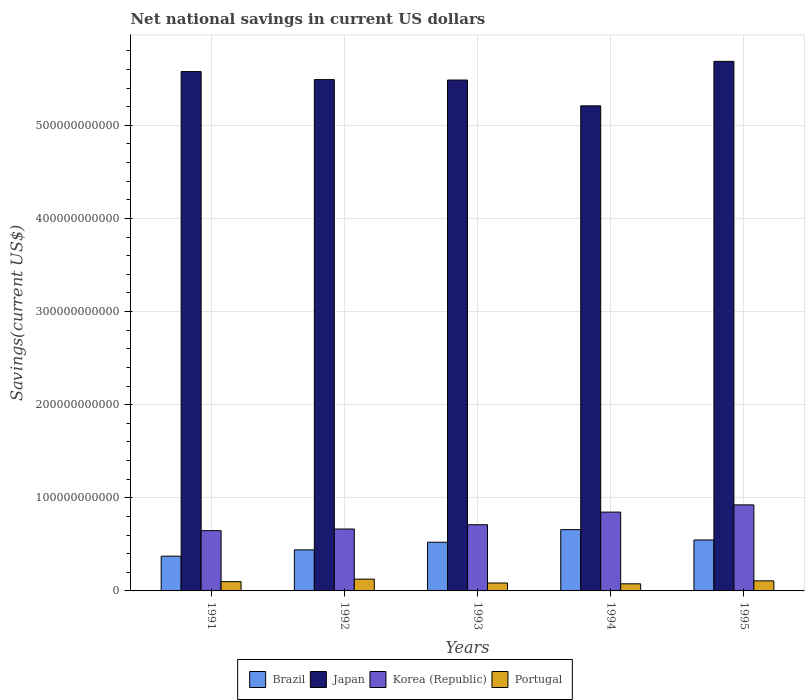Are the number of bars per tick equal to the number of legend labels?
Keep it short and to the point. Yes. Are the number of bars on each tick of the X-axis equal?
Give a very brief answer. Yes. How many bars are there on the 5th tick from the left?
Your answer should be very brief. 4. How many bars are there on the 2nd tick from the right?
Ensure brevity in your answer.  4. In how many cases, is the number of bars for a given year not equal to the number of legend labels?
Provide a succinct answer. 0. What is the net national savings in Brazil in 1993?
Provide a short and direct response. 5.23e+1. Across all years, what is the maximum net national savings in Japan?
Your answer should be very brief. 5.69e+11. Across all years, what is the minimum net national savings in Brazil?
Your answer should be compact. 3.73e+1. In which year was the net national savings in Brazil minimum?
Ensure brevity in your answer.  1991. What is the total net national savings in Korea (Republic) in the graph?
Give a very brief answer. 3.79e+11. What is the difference between the net national savings in Brazil in 1992 and that in 1993?
Give a very brief answer. -8.19e+09. What is the difference between the net national savings in Brazil in 1992 and the net national savings in Korea (Republic) in 1995?
Keep it short and to the point. -4.83e+1. What is the average net national savings in Korea (Republic) per year?
Your answer should be compact. 7.58e+1. In the year 1995, what is the difference between the net national savings in Japan and net national savings in Portugal?
Offer a terse response. 5.58e+11. What is the ratio of the net national savings in Portugal in 1993 to that in 1995?
Your response must be concise. 0.79. What is the difference between the highest and the second highest net national savings in Brazil?
Your response must be concise. 1.11e+1. What is the difference between the highest and the lowest net national savings in Japan?
Keep it short and to the point. 4.78e+1. In how many years, is the net national savings in Portugal greater than the average net national savings in Portugal taken over all years?
Give a very brief answer. 3. What does the 4th bar from the left in 1995 represents?
Offer a terse response. Portugal. What does the 1st bar from the right in 1993 represents?
Offer a terse response. Portugal. Is it the case that in every year, the sum of the net national savings in Japan and net national savings in Brazil is greater than the net national savings in Korea (Republic)?
Provide a short and direct response. Yes. How many years are there in the graph?
Keep it short and to the point. 5. What is the difference between two consecutive major ticks on the Y-axis?
Provide a short and direct response. 1.00e+11. Are the values on the major ticks of Y-axis written in scientific E-notation?
Ensure brevity in your answer.  No. Does the graph contain any zero values?
Offer a terse response. No. What is the title of the graph?
Your answer should be very brief. Net national savings in current US dollars. What is the label or title of the Y-axis?
Make the answer very short. Savings(current US$). What is the Savings(current US$) in Brazil in 1991?
Provide a succinct answer. 3.73e+1. What is the Savings(current US$) in Japan in 1991?
Your answer should be very brief. 5.58e+11. What is the Savings(current US$) in Korea (Republic) in 1991?
Offer a terse response. 6.47e+1. What is the Savings(current US$) of Portugal in 1991?
Offer a terse response. 9.96e+09. What is the Savings(current US$) in Brazil in 1992?
Your response must be concise. 4.41e+1. What is the Savings(current US$) in Japan in 1992?
Your response must be concise. 5.49e+11. What is the Savings(current US$) of Korea (Republic) in 1992?
Your answer should be compact. 6.65e+1. What is the Savings(current US$) in Portugal in 1992?
Make the answer very short. 1.27e+1. What is the Savings(current US$) of Brazil in 1993?
Offer a terse response. 5.23e+1. What is the Savings(current US$) of Japan in 1993?
Your answer should be very brief. 5.49e+11. What is the Savings(current US$) of Korea (Republic) in 1993?
Your response must be concise. 7.11e+1. What is the Savings(current US$) of Portugal in 1993?
Keep it short and to the point. 8.51e+09. What is the Savings(current US$) in Brazil in 1994?
Give a very brief answer. 6.58e+1. What is the Savings(current US$) of Japan in 1994?
Ensure brevity in your answer.  5.21e+11. What is the Savings(current US$) of Korea (Republic) in 1994?
Your answer should be very brief. 8.46e+1. What is the Savings(current US$) in Portugal in 1994?
Provide a short and direct response. 7.64e+09. What is the Savings(current US$) in Brazil in 1995?
Ensure brevity in your answer.  5.47e+1. What is the Savings(current US$) of Japan in 1995?
Your answer should be very brief. 5.69e+11. What is the Savings(current US$) in Korea (Republic) in 1995?
Provide a short and direct response. 9.24e+1. What is the Savings(current US$) in Portugal in 1995?
Offer a very short reply. 1.08e+1. Across all years, what is the maximum Savings(current US$) in Brazil?
Your answer should be very brief. 6.58e+1. Across all years, what is the maximum Savings(current US$) of Japan?
Give a very brief answer. 5.69e+11. Across all years, what is the maximum Savings(current US$) of Korea (Republic)?
Provide a succinct answer. 9.24e+1. Across all years, what is the maximum Savings(current US$) in Portugal?
Your response must be concise. 1.27e+1. Across all years, what is the minimum Savings(current US$) in Brazil?
Provide a short and direct response. 3.73e+1. Across all years, what is the minimum Savings(current US$) of Japan?
Ensure brevity in your answer.  5.21e+11. Across all years, what is the minimum Savings(current US$) in Korea (Republic)?
Your answer should be compact. 6.47e+1. Across all years, what is the minimum Savings(current US$) of Portugal?
Keep it short and to the point. 7.64e+09. What is the total Savings(current US$) of Brazil in the graph?
Offer a terse response. 2.54e+11. What is the total Savings(current US$) in Japan in the graph?
Offer a terse response. 2.74e+12. What is the total Savings(current US$) of Korea (Republic) in the graph?
Offer a terse response. 3.79e+11. What is the total Savings(current US$) in Portugal in the graph?
Make the answer very short. 4.96e+1. What is the difference between the Savings(current US$) in Brazil in 1991 and that in 1992?
Make the answer very short. -6.80e+09. What is the difference between the Savings(current US$) in Japan in 1991 and that in 1992?
Provide a short and direct response. 8.63e+09. What is the difference between the Savings(current US$) in Korea (Republic) in 1991 and that in 1992?
Keep it short and to the point. -1.76e+09. What is the difference between the Savings(current US$) of Portugal in 1991 and that in 1992?
Provide a short and direct response. -2.73e+09. What is the difference between the Savings(current US$) of Brazil in 1991 and that in 1993?
Your answer should be compact. -1.50e+1. What is the difference between the Savings(current US$) in Japan in 1991 and that in 1993?
Provide a succinct answer. 9.08e+09. What is the difference between the Savings(current US$) of Korea (Republic) in 1991 and that in 1993?
Keep it short and to the point. -6.36e+09. What is the difference between the Savings(current US$) in Portugal in 1991 and that in 1993?
Provide a succinct answer. 1.45e+09. What is the difference between the Savings(current US$) of Brazil in 1991 and that in 1994?
Ensure brevity in your answer.  -2.85e+1. What is the difference between the Savings(current US$) of Japan in 1991 and that in 1994?
Ensure brevity in your answer.  3.68e+1. What is the difference between the Savings(current US$) of Korea (Republic) in 1991 and that in 1994?
Ensure brevity in your answer.  -1.99e+1. What is the difference between the Savings(current US$) in Portugal in 1991 and that in 1994?
Your answer should be compact. 2.31e+09. What is the difference between the Savings(current US$) of Brazil in 1991 and that in 1995?
Offer a terse response. -1.74e+1. What is the difference between the Savings(current US$) in Japan in 1991 and that in 1995?
Offer a terse response. -1.10e+1. What is the difference between the Savings(current US$) in Korea (Republic) in 1991 and that in 1995?
Keep it short and to the point. -2.77e+1. What is the difference between the Savings(current US$) in Portugal in 1991 and that in 1995?
Provide a short and direct response. -8.49e+08. What is the difference between the Savings(current US$) of Brazil in 1992 and that in 1993?
Ensure brevity in your answer.  -8.19e+09. What is the difference between the Savings(current US$) in Japan in 1992 and that in 1993?
Ensure brevity in your answer.  4.47e+08. What is the difference between the Savings(current US$) of Korea (Republic) in 1992 and that in 1993?
Offer a terse response. -4.60e+09. What is the difference between the Savings(current US$) of Portugal in 1992 and that in 1993?
Your response must be concise. 4.18e+09. What is the difference between the Savings(current US$) in Brazil in 1992 and that in 1994?
Offer a terse response. -2.17e+1. What is the difference between the Savings(current US$) of Japan in 1992 and that in 1994?
Ensure brevity in your answer.  2.81e+1. What is the difference between the Savings(current US$) of Korea (Republic) in 1992 and that in 1994?
Give a very brief answer. -1.82e+1. What is the difference between the Savings(current US$) of Portugal in 1992 and that in 1994?
Offer a very short reply. 5.04e+09. What is the difference between the Savings(current US$) in Brazil in 1992 and that in 1995?
Make the answer very short. -1.06e+1. What is the difference between the Savings(current US$) in Japan in 1992 and that in 1995?
Provide a short and direct response. -1.96e+1. What is the difference between the Savings(current US$) of Korea (Republic) in 1992 and that in 1995?
Give a very brief answer. -2.59e+1. What is the difference between the Savings(current US$) in Portugal in 1992 and that in 1995?
Keep it short and to the point. 1.88e+09. What is the difference between the Savings(current US$) in Brazil in 1993 and that in 1994?
Keep it short and to the point. -1.35e+1. What is the difference between the Savings(current US$) in Japan in 1993 and that in 1994?
Provide a succinct answer. 2.77e+1. What is the difference between the Savings(current US$) of Korea (Republic) in 1993 and that in 1994?
Provide a succinct answer. -1.36e+1. What is the difference between the Savings(current US$) of Portugal in 1993 and that in 1994?
Give a very brief answer. 8.62e+08. What is the difference between the Savings(current US$) of Brazil in 1993 and that in 1995?
Keep it short and to the point. -2.41e+09. What is the difference between the Savings(current US$) in Japan in 1993 and that in 1995?
Give a very brief answer. -2.01e+1. What is the difference between the Savings(current US$) in Korea (Republic) in 1993 and that in 1995?
Ensure brevity in your answer.  -2.13e+1. What is the difference between the Savings(current US$) in Portugal in 1993 and that in 1995?
Give a very brief answer. -2.30e+09. What is the difference between the Savings(current US$) of Brazil in 1994 and that in 1995?
Provide a succinct answer. 1.11e+1. What is the difference between the Savings(current US$) in Japan in 1994 and that in 1995?
Offer a very short reply. -4.78e+1. What is the difference between the Savings(current US$) of Korea (Republic) in 1994 and that in 1995?
Your response must be concise. -7.75e+09. What is the difference between the Savings(current US$) of Portugal in 1994 and that in 1995?
Your answer should be very brief. -3.16e+09. What is the difference between the Savings(current US$) of Brazil in 1991 and the Savings(current US$) of Japan in 1992?
Make the answer very short. -5.12e+11. What is the difference between the Savings(current US$) in Brazil in 1991 and the Savings(current US$) in Korea (Republic) in 1992?
Make the answer very short. -2.92e+1. What is the difference between the Savings(current US$) of Brazil in 1991 and the Savings(current US$) of Portugal in 1992?
Ensure brevity in your answer.  2.46e+1. What is the difference between the Savings(current US$) of Japan in 1991 and the Savings(current US$) of Korea (Republic) in 1992?
Give a very brief answer. 4.91e+11. What is the difference between the Savings(current US$) in Japan in 1991 and the Savings(current US$) in Portugal in 1992?
Keep it short and to the point. 5.45e+11. What is the difference between the Savings(current US$) in Korea (Republic) in 1991 and the Savings(current US$) in Portugal in 1992?
Make the answer very short. 5.20e+1. What is the difference between the Savings(current US$) of Brazil in 1991 and the Savings(current US$) of Japan in 1993?
Give a very brief answer. -5.11e+11. What is the difference between the Savings(current US$) in Brazil in 1991 and the Savings(current US$) in Korea (Republic) in 1993?
Keep it short and to the point. -3.38e+1. What is the difference between the Savings(current US$) in Brazil in 1991 and the Savings(current US$) in Portugal in 1993?
Give a very brief answer. 2.88e+1. What is the difference between the Savings(current US$) in Japan in 1991 and the Savings(current US$) in Korea (Republic) in 1993?
Give a very brief answer. 4.87e+11. What is the difference between the Savings(current US$) of Japan in 1991 and the Savings(current US$) of Portugal in 1993?
Offer a very short reply. 5.49e+11. What is the difference between the Savings(current US$) of Korea (Republic) in 1991 and the Savings(current US$) of Portugal in 1993?
Provide a short and direct response. 5.62e+1. What is the difference between the Savings(current US$) in Brazil in 1991 and the Savings(current US$) in Japan in 1994?
Provide a succinct answer. -4.84e+11. What is the difference between the Savings(current US$) in Brazil in 1991 and the Savings(current US$) in Korea (Republic) in 1994?
Ensure brevity in your answer.  -4.73e+1. What is the difference between the Savings(current US$) of Brazil in 1991 and the Savings(current US$) of Portugal in 1994?
Ensure brevity in your answer.  2.97e+1. What is the difference between the Savings(current US$) of Japan in 1991 and the Savings(current US$) of Korea (Republic) in 1994?
Provide a succinct answer. 4.73e+11. What is the difference between the Savings(current US$) in Japan in 1991 and the Savings(current US$) in Portugal in 1994?
Keep it short and to the point. 5.50e+11. What is the difference between the Savings(current US$) in Korea (Republic) in 1991 and the Savings(current US$) in Portugal in 1994?
Your answer should be compact. 5.71e+1. What is the difference between the Savings(current US$) in Brazil in 1991 and the Savings(current US$) in Japan in 1995?
Your response must be concise. -5.31e+11. What is the difference between the Savings(current US$) of Brazil in 1991 and the Savings(current US$) of Korea (Republic) in 1995?
Provide a short and direct response. -5.51e+1. What is the difference between the Savings(current US$) in Brazil in 1991 and the Savings(current US$) in Portugal in 1995?
Offer a terse response. 2.65e+1. What is the difference between the Savings(current US$) of Japan in 1991 and the Savings(current US$) of Korea (Republic) in 1995?
Keep it short and to the point. 4.65e+11. What is the difference between the Savings(current US$) of Japan in 1991 and the Savings(current US$) of Portugal in 1995?
Offer a terse response. 5.47e+11. What is the difference between the Savings(current US$) of Korea (Republic) in 1991 and the Savings(current US$) of Portugal in 1995?
Make the answer very short. 5.39e+1. What is the difference between the Savings(current US$) of Brazil in 1992 and the Savings(current US$) of Japan in 1993?
Your answer should be very brief. -5.05e+11. What is the difference between the Savings(current US$) of Brazil in 1992 and the Savings(current US$) of Korea (Republic) in 1993?
Your answer should be compact. -2.70e+1. What is the difference between the Savings(current US$) in Brazil in 1992 and the Savings(current US$) in Portugal in 1993?
Offer a very short reply. 3.56e+1. What is the difference between the Savings(current US$) in Japan in 1992 and the Savings(current US$) in Korea (Republic) in 1993?
Provide a short and direct response. 4.78e+11. What is the difference between the Savings(current US$) of Japan in 1992 and the Savings(current US$) of Portugal in 1993?
Your answer should be very brief. 5.41e+11. What is the difference between the Savings(current US$) in Korea (Republic) in 1992 and the Savings(current US$) in Portugal in 1993?
Offer a terse response. 5.80e+1. What is the difference between the Savings(current US$) of Brazil in 1992 and the Savings(current US$) of Japan in 1994?
Your response must be concise. -4.77e+11. What is the difference between the Savings(current US$) of Brazil in 1992 and the Savings(current US$) of Korea (Republic) in 1994?
Your answer should be compact. -4.05e+1. What is the difference between the Savings(current US$) in Brazil in 1992 and the Savings(current US$) in Portugal in 1994?
Your answer should be very brief. 3.65e+1. What is the difference between the Savings(current US$) in Japan in 1992 and the Savings(current US$) in Korea (Republic) in 1994?
Provide a short and direct response. 4.64e+11. What is the difference between the Savings(current US$) in Japan in 1992 and the Savings(current US$) in Portugal in 1994?
Your answer should be very brief. 5.41e+11. What is the difference between the Savings(current US$) of Korea (Republic) in 1992 and the Savings(current US$) of Portugal in 1994?
Your response must be concise. 5.88e+1. What is the difference between the Savings(current US$) of Brazil in 1992 and the Savings(current US$) of Japan in 1995?
Provide a succinct answer. -5.25e+11. What is the difference between the Savings(current US$) of Brazil in 1992 and the Savings(current US$) of Korea (Republic) in 1995?
Your response must be concise. -4.83e+1. What is the difference between the Savings(current US$) in Brazil in 1992 and the Savings(current US$) in Portugal in 1995?
Your response must be concise. 3.33e+1. What is the difference between the Savings(current US$) of Japan in 1992 and the Savings(current US$) of Korea (Republic) in 1995?
Offer a very short reply. 4.57e+11. What is the difference between the Savings(current US$) in Japan in 1992 and the Savings(current US$) in Portugal in 1995?
Keep it short and to the point. 5.38e+11. What is the difference between the Savings(current US$) in Korea (Republic) in 1992 and the Savings(current US$) in Portugal in 1995?
Keep it short and to the point. 5.57e+1. What is the difference between the Savings(current US$) of Brazil in 1993 and the Savings(current US$) of Japan in 1994?
Ensure brevity in your answer.  -4.69e+11. What is the difference between the Savings(current US$) of Brazil in 1993 and the Savings(current US$) of Korea (Republic) in 1994?
Keep it short and to the point. -3.23e+1. What is the difference between the Savings(current US$) of Brazil in 1993 and the Savings(current US$) of Portugal in 1994?
Offer a very short reply. 4.46e+1. What is the difference between the Savings(current US$) of Japan in 1993 and the Savings(current US$) of Korea (Republic) in 1994?
Your answer should be very brief. 4.64e+11. What is the difference between the Savings(current US$) of Japan in 1993 and the Savings(current US$) of Portugal in 1994?
Your answer should be compact. 5.41e+11. What is the difference between the Savings(current US$) of Korea (Republic) in 1993 and the Savings(current US$) of Portugal in 1994?
Provide a succinct answer. 6.34e+1. What is the difference between the Savings(current US$) in Brazil in 1993 and the Savings(current US$) in Japan in 1995?
Make the answer very short. -5.16e+11. What is the difference between the Savings(current US$) of Brazil in 1993 and the Savings(current US$) of Korea (Republic) in 1995?
Ensure brevity in your answer.  -4.01e+1. What is the difference between the Savings(current US$) in Brazil in 1993 and the Savings(current US$) in Portugal in 1995?
Your answer should be compact. 4.15e+1. What is the difference between the Savings(current US$) of Japan in 1993 and the Savings(current US$) of Korea (Republic) in 1995?
Keep it short and to the point. 4.56e+11. What is the difference between the Savings(current US$) of Japan in 1993 and the Savings(current US$) of Portugal in 1995?
Make the answer very short. 5.38e+11. What is the difference between the Savings(current US$) in Korea (Republic) in 1993 and the Savings(current US$) in Portugal in 1995?
Your response must be concise. 6.03e+1. What is the difference between the Savings(current US$) in Brazil in 1994 and the Savings(current US$) in Japan in 1995?
Provide a succinct answer. -5.03e+11. What is the difference between the Savings(current US$) in Brazil in 1994 and the Savings(current US$) in Korea (Republic) in 1995?
Keep it short and to the point. -2.66e+1. What is the difference between the Savings(current US$) of Brazil in 1994 and the Savings(current US$) of Portugal in 1995?
Offer a terse response. 5.50e+1. What is the difference between the Savings(current US$) of Japan in 1994 and the Savings(current US$) of Korea (Republic) in 1995?
Your answer should be very brief. 4.29e+11. What is the difference between the Savings(current US$) in Japan in 1994 and the Savings(current US$) in Portugal in 1995?
Your response must be concise. 5.10e+11. What is the difference between the Savings(current US$) of Korea (Republic) in 1994 and the Savings(current US$) of Portugal in 1995?
Offer a very short reply. 7.38e+1. What is the average Savings(current US$) of Brazil per year?
Provide a succinct answer. 5.08e+1. What is the average Savings(current US$) of Japan per year?
Keep it short and to the point. 5.49e+11. What is the average Savings(current US$) of Korea (Republic) per year?
Keep it short and to the point. 7.58e+1. What is the average Savings(current US$) of Portugal per year?
Give a very brief answer. 9.92e+09. In the year 1991, what is the difference between the Savings(current US$) in Brazil and Savings(current US$) in Japan?
Your response must be concise. -5.20e+11. In the year 1991, what is the difference between the Savings(current US$) in Brazil and Savings(current US$) in Korea (Republic)?
Give a very brief answer. -2.74e+1. In the year 1991, what is the difference between the Savings(current US$) in Brazil and Savings(current US$) in Portugal?
Give a very brief answer. 2.73e+1. In the year 1991, what is the difference between the Savings(current US$) in Japan and Savings(current US$) in Korea (Republic)?
Provide a short and direct response. 4.93e+11. In the year 1991, what is the difference between the Savings(current US$) of Japan and Savings(current US$) of Portugal?
Keep it short and to the point. 5.48e+11. In the year 1991, what is the difference between the Savings(current US$) in Korea (Republic) and Savings(current US$) in Portugal?
Your answer should be compact. 5.47e+1. In the year 1992, what is the difference between the Savings(current US$) of Brazil and Savings(current US$) of Japan?
Provide a short and direct response. -5.05e+11. In the year 1992, what is the difference between the Savings(current US$) in Brazil and Savings(current US$) in Korea (Republic)?
Offer a terse response. -2.24e+1. In the year 1992, what is the difference between the Savings(current US$) in Brazil and Savings(current US$) in Portugal?
Keep it short and to the point. 3.14e+1. In the year 1992, what is the difference between the Savings(current US$) in Japan and Savings(current US$) in Korea (Republic)?
Provide a succinct answer. 4.83e+11. In the year 1992, what is the difference between the Savings(current US$) in Japan and Savings(current US$) in Portugal?
Keep it short and to the point. 5.36e+11. In the year 1992, what is the difference between the Savings(current US$) of Korea (Republic) and Savings(current US$) of Portugal?
Give a very brief answer. 5.38e+1. In the year 1993, what is the difference between the Savings(current US$) in Brazil and Savings(current US$) in Japan?
Your answer should be compact. -4.96e+11. In the year 1993, what is the difference between the Savings(current US$) of Brazil and Savings(current US$) of Korea (Republic)?
Ensure brevity in your answer.  -1.88e+1. In the year 1993, what is the difference between the Savings(current US$) of Brazil and Savings(current US$) of Portugal?
Offer a terse response. 4.38e+1. In the year 1993, what is the difference between the Savings(current US$) in Japan and Savings(current US$) in Korea (Republic)?
Keep it short and to the point. 4.78e+11. In the year 1993, what is the difference between the Savings(current US$) in Japan and Savings(current US$) in Portugal?
Give a very brief answer. 5.40e+11. In the year 1993, what is the difference between the Savings(current US$) in Korea (Republic) and Savings(current US$) in Portugal?
Ensure brevity in your answer.  6.26e+1. In the year 1994, what is the difference between the Savings(current US$) of Brazil and Savings(current US$) of Japan?
Your answer should be very brief. -4.55e+11. In the year 1994, what is the difference between the Savings(current US$) in Brazil and Savings(current US$) in Korea (Republic)?
Ensure brevity in your answer.  -1.88e+1. In the year 1994, what is the difference between the Savings(current US$) of Brazil and Savings(current US$) of Portugal?
Keep it short and to the point. 5.82e+1. In the year 1994, what is the difference between the Savings(current US$) of Japan and Savings(current US$) of Korea (Republic)?
Provide a succinct answer. 4.36e+11. In the year 1994, what is the difference between the Savings(current US$) of Japan and Savings(current US$) of Portugal?
Provide a short and direct response. 5.13e+11. In the year 1994, what is the difference between the Savings(current US$) in Korea (Republic) and Savings(current US$) in Portugal?
Make the answer very short. 7.70e+1. In the year 1995, what is the difference between the Savings(current US$) in Brazil and Savings(current US$) in Japan?
Keep it short and to the point. -5.14e+11. In the year 1995, what is the difference between the Savings(current US$) in Brazil and Savings(current US$) in Korea (Republic)?
Give a very brief answer. -3.77e+1. In the year 1995, what is the difference between the Savings(current US$) of Brazil and Savings(current US$) of Portugal?
Offer a very short reply. 4.39e+1. In the year 1995, what is the difference between the Savings(current US$) in Japan and Savings(current US$) in Korea (Republic)?
Offer a terse response. 4.76e+11. In the year 1995, what is the difference between the Savings(current US$) in Japan and Savings(current US$) in Portugal?
Offer a terse response. 5.58e+11. In the year 1995, what is the difference between the Savings(current US$) of Korea (Republic) and Savings(current US$) of Portugal?
Provide a succinct answer. 8.16e+1. What is the ratio of the Savings(current US$) in Brazil in 1991 to that in 1992?
Your answer should be very brief. 0.85. What is the ratio of the Savings(current US$) in Japan in 1991 to that in 1992?
Keep it short and to the point. 1.02. What is the ratio of the Savings(current US$) in Korea (Republic) in 1991 to that in 1992?
Keep it short and to the point. 0.97. What is the ratio of the Savings(current US$) of Portugal in 1991 to that in 1992?
Make the answer very short. 0.79. What is the ratio of the Savings(current US$) in Brazil in 1991 to that in 1993?
Keep it short and to the point. 0.71. What is the ratio of the Savings(current US$) of Japan in 1991 to that in 1993?
Your answer should be compact. 1.02. What is the ratio of the Savings(current US$) of Korea (Republic) in 1991 to that in 1993?
Offer a very short reply. 0.91. What is the ratio of the Savings(current US$) of Portugal in 1991 to that in 1993?
Ensure brevity in your answer.  1.17. What is the ratio of the Savings(current US$) in Brazil in 1991 to that in 1994?
Keep it short and to the point. 0.57. What is the ratio of the Savings(current US$) of Japan in 1991 to that in 1994?
Keep it short and to the point. 1.07. What is the ratio of the Savings(current US$) in Korea (Republic) in 1991 to that in 1994?
Keep it short and to the point. 0.76. What is the ratio of the Savings(current US$) in Portugal in 1991 to that in 1994?
Offer a very short reply. 1.3. What is the ratio of the Savings(current US$) in Brazil in 1991 to that in 1995?
Keep it short and to the point. 0.68. What is the ratio of the Savings(current US$) in Japan in 1991 to that in 1995?
Keep it short and to the point. 0.98. What is the ratio of the Savings(current US$) in Korea (Republic) in 1991 to that in 1995?
Offer a terse response. 0.7. What is the ratio of the Savings(current US$) of Portugal in 1991 to that in 1995?
Provide a succinct answer. 0.92. What is the ratio of the Savings(current US$) in Brazil in 1992 to that in 1993?
Make the answer very short. 0.84. What is the ratio of the Savings(current US$) of Japan in 1992 to that in 1993?
Your response must be concise. 1. What is the ratio of the Savings(current US$) of Korea (Republic) in 1992 to that in 1993?
Offer a terse response. 0.94. What is the ratio of the Savings(current US$) of Portugal in 1992 to that in 1993?
Offer a very short reply. 1.49. What is the ratio of the Savings(current US$) of Brazil in 1992 to that in 1994?
Provide a succinct answer. 0.67. What is the ratio of the Savings(current US$) of Japan in 1992 to that in 1994?
Keep it short and to the point. 1.05. What is the ratio of the Savings(current US$) of Korea (Republic) in 1992 to that in 1994?
Your answer should be compact. 0.79. What is the ratio of the Savings(current US$) in Portugal in 1992 to that in 1994?
Offer a terse response. 1.66. What is the ratio of the Savings(current US$) of Brazil in 1992 to that in 1995?
Ensure brevity in your answer.  0.81. What is the ratio of the Savings(current US$) in Japan in 1992 to that in 1995?
Ensure brevity in your answer.  0.97. What is the ratio of the Savings(current US$) in Korea (Republic) in 1992 to that in 1995?
Your response must be concise. 0.72. What is the ratio of the Savings(current US$) in Portugal in 1992 to that in 1995?
Offer a terse response. 1.17. What is the ratio of the Savings(current US$) in Brazil in 1993 to that in 1994?
Ensure brevity in your answer.  0.79. What is the ratio of the Savings(current US$) in Japan in 1993 to that in 1994?
Provide a short and direct response. 1.05. What is the ratio of the Savings(current US$) of Korea (Republic) in 1993 to that in 1994?
Keep it short and to the point. 0.84. What is the ratio of the Savings(current US$) in Portugal in 1993 to that in 1994?
Provide a short and direct response. 1.11. What is the ratio of the Savings(current US$) in Brazil in 1993 to that in 1995?
Provide a short and direct response. 0.96. What is the ratio of the Savings(current US$) of Japan in 1993 to that in 1995?
Your response must be concise. 0.96. What is the ratio of the Savings(current US$) in Korea (Republic) in 1993 to that in 1995?
Keep it short and to the point. 0.77. What is the ratio of the Savings(current US$) in Portugal in 1993 to that in 1995?
Ensure brevity in your answer.  0.79. What is the ratio of the Savings(current US$) in Brazil in 1994 to that in 1995?
Ensure brevity in your answer.  1.2. What is the ratio of the Savings(current US$) in Japan in 1994 to that in 1995?
Offer a very short reply. 0.92. What is the ratio of the Savings(current US$) in Korea (Republic) in 1994 to that in 1995?
Your response must be concise. 0.92. What is the ratio of the Savings(current US$) of Portugal in 1994 to that in 1995?
Keep it short and to the point. 0.71. What is the difference between the highest and the second highest Savings(current US$) of Brazil?
Offer a very short reply. 1.11e+1. What is the difference between the highest and the second highest Savings(current US$) of Japan?
Give a very brief answer. 1.10e+1. What is the difference between the highest and the second highest Savings(current US$) in Korea (Republic)?
Offer a very short reply. 7.75e+09. What is the difference between the highest and the second highest Savings(current US$) in Portugal?
Your response must be concise. 1.88e+09. What is the difference between the highest and the lowest Savings(current US$) in Brazil?
Your response must be concise. 2.85e+1. What is the difference between the highest and the lowest Savings(current US$) of Japan?
Make the answer very short. 4.78e+1. What is the difference between the highest and the lowest Savings(current US$) of Korea (Republic)?
Provide a succinct answer. 2.77e+1. What is the difference between the highest and the lowest Savings(current US$) of Portugal?
Give a very brief answer. 5.04e+09. 